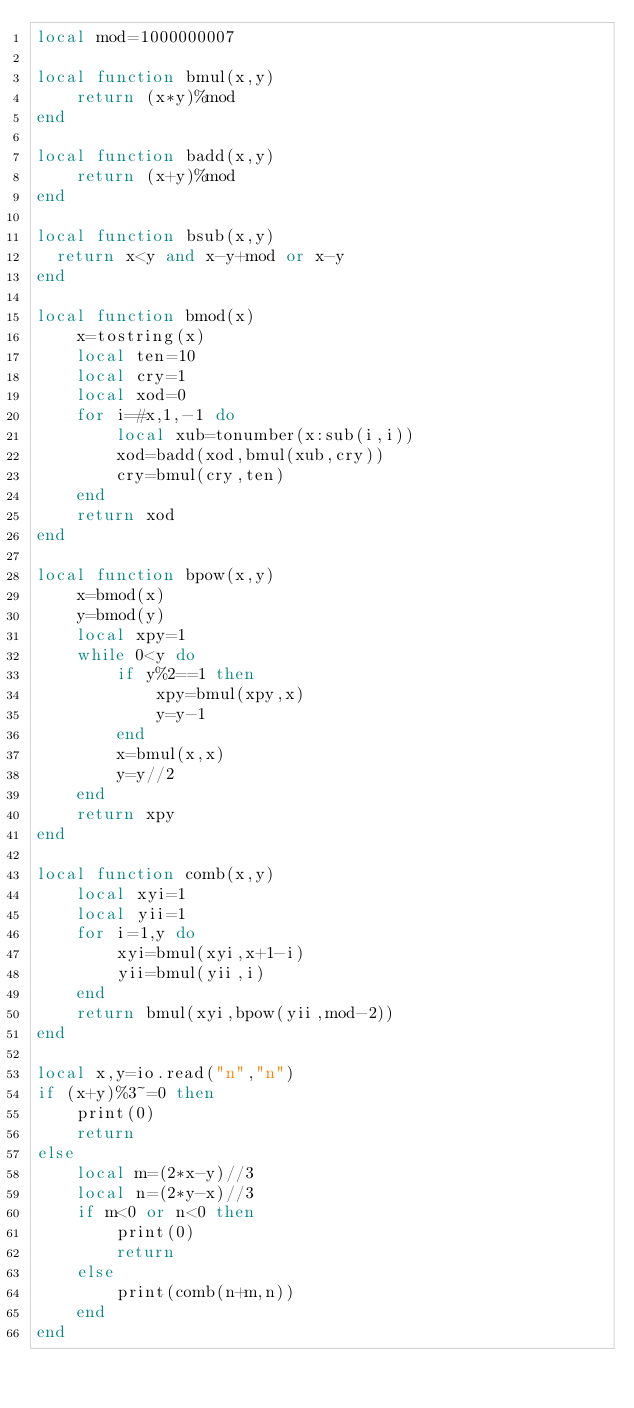Convert code to text. <code><loc_0><loc_0><loc_500><loc_500><_Lua_>local mod=1000000007

local function bmul(x,y)
    return (x*y)%mod
end

local function badd(x,y)
    return (x+y)%mod
end

local function bsub(x,y)
  return x<y and x-y+mod or x-y
end

local function bmod(x)
    x=tostring(x)
    local ten=10
    local cry=1
    local xod=0
    for i=#x,1,-1 do
        local xub=tonumber(x:sub(i,i))
        xod=badd(xod,bmul(xub,cry))
        cry=bmul(cry,ten)
    end
    return xod
end

local function bpow(x,y)
    x=bmod(x)
    y=bmod(y)
    local xpy=1
    while 0<y do
        if y%2==1 then
            xpy=bmul(xpy,x)
            y=y-1
        end
        x=bmul(x,x)
        y=y//2
    end
    return xpy
end

local function comb(x,y)
    local xyi=1
    local yii=1
    for i=1,y do
        xyi=bmul(xyi,x+1-i)
        yii=bmul(yii,i)
    end
    return bmul(xyi,bpow(yii,mod-2))
end

local x,y=io.read("n","n")
if (x+y)%3~=0 then
    print(0)
    return
else
    local m=(2*x-y)//3
    local n=(2*y-x)//3
    if m<0 or n<0 then
        print(0)
        return
    else
        print(comb(n+m,n))
    end
end</code> 